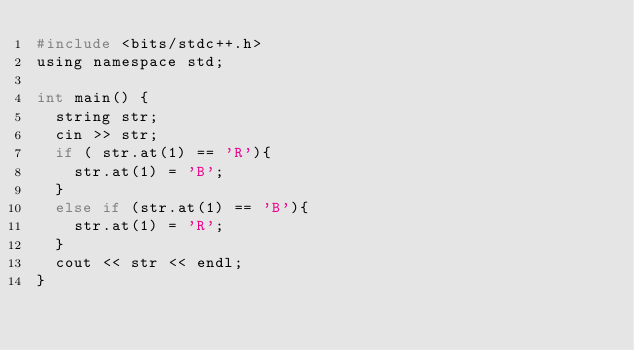<code> <loc_0><loc_0><loc_500><loc_500><_C_>#include <bits/stdc++.h>
using namespace std;

int main() {
  string str;
  cin >> str;
  if ( str.at(1) == 'R'){
    str.at(1) = 'B';
  }
  else if (str.at(1) == 'B'){
    str.at(1) = 'R';
  }
  cout << str << endl;
}

</code> 